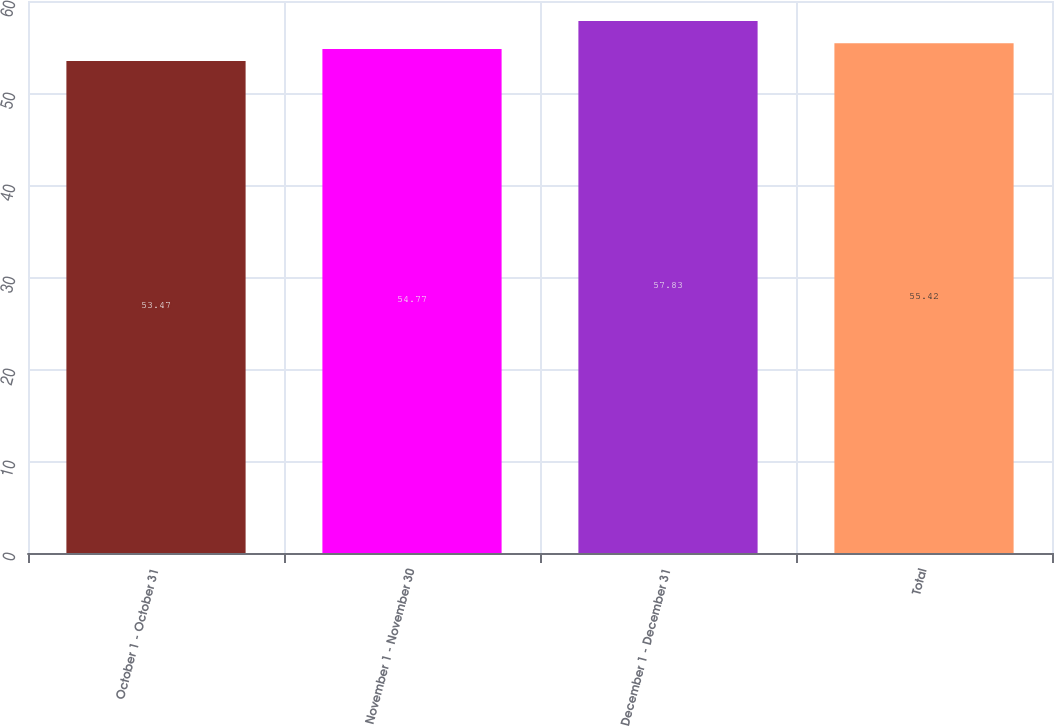<chart> <loc_0><loc_0><loc_500><loc_500><bar_chart><fcel>October 1 - October 31<fcel>November 1 - November 30<fcel>December 1 - December 31<fcel>Total<nl><fcel>53.47<fcel>54.77<fcel>57.83<fcel>55.42<nl></chart> 